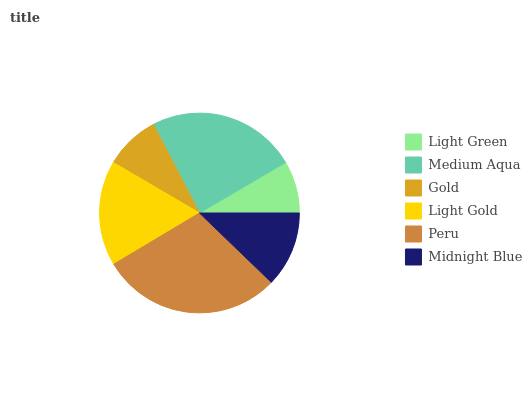Is Light Green the minimum?
Answer yes or no. Yes. Is Peru the maximum?
Answer yes or no. Yes. Is Medium Aqua the minimum?
Answer yes or no. No. Is Medium Aqua the maximum?
Answer yes or no. No. Is Medium Aqua greater than Light Green?
Answer yes or no. Yes. Is Light Green less than Medium Aqua?
Answer yes or no. Yes. Is Light Green greater than Medium Aqua?
Answer yes or no. No. Is Medium Aqua less than Light Green?
Answer yes or no. No. Is Light Gold the high median?
Answer yes or no. Yes. Is Midnight Blue the low median?
Answer yes or no. Yes. Is Light Green the high median?
Answer yes or no. No. Is Medium Aqua the low median?
Answer yes or no. No. 